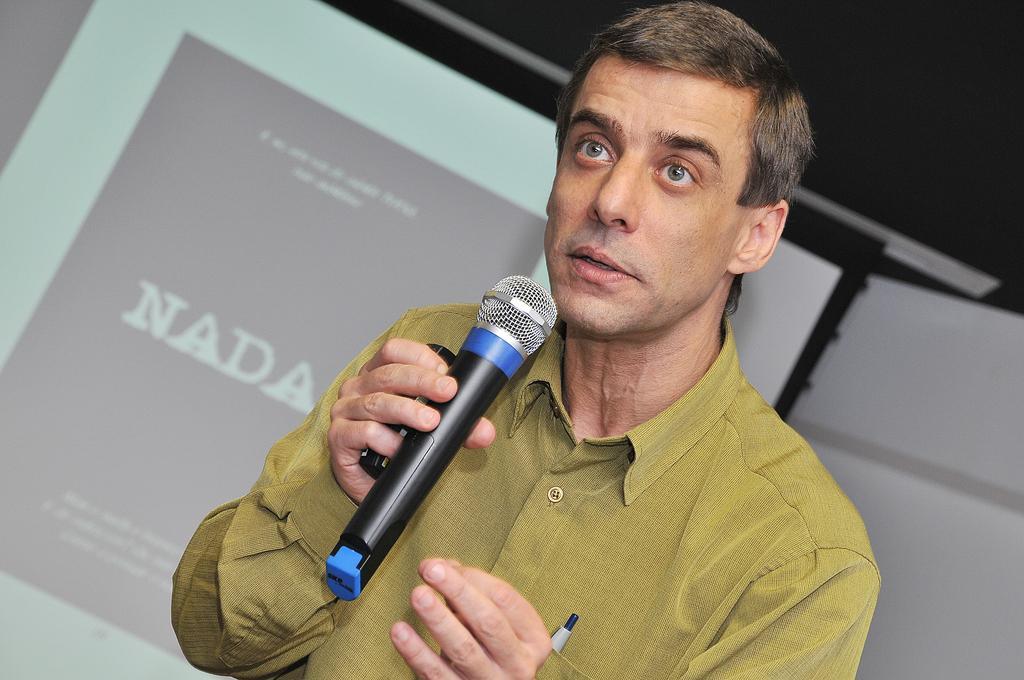Describe this image in one or two sentences. This person holding microphone and talking wear yellow color shirt,behind this person we can see screen. 